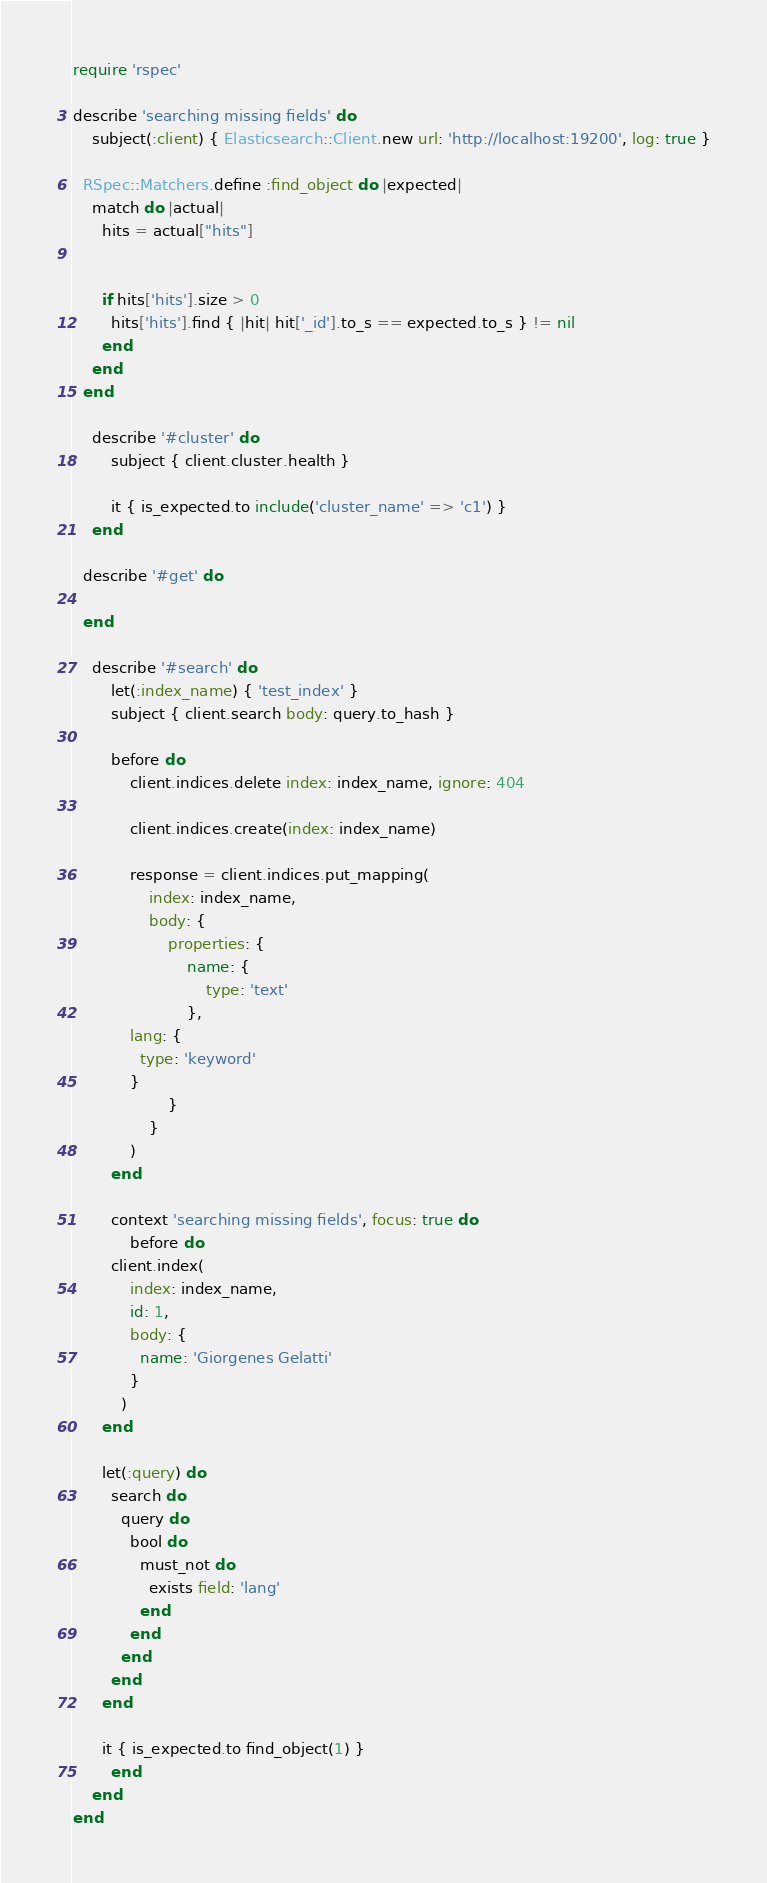<code> <loc_0><loc_0><loc_500><loc_500><_Ruby_>require 'rspec'

describe 'searching missing fields' do
	subject(:client) { Elasticsearch::Client.new url: 'http://localhost:19200', log: true }

  RSpec::Matchers.define :find_object do |expected|
    match do |actual|
      hits = actual["hits"]


      if hits['hits'].size > 0
        hits['hits'].find { |hit| hit['_id'].to_s == expected.to_s } != nil
      end
    end
  end

	describe '#cluster' do
		subject { client.cluster.health }

		it { is_expected.to include('cluster_name' => 'c1') }
	end

  describe '#get' do
    
  end

	describe '#search' do
		let(:index_name) { 'test_index' }
		subject { client.search body: query.to_hash }

		before do
			client.indices.delete index: index_name, ignore: 404

			client.indices.create(index: index_name)

			response = client.indices.put_mapping(
				index: index_name,
				body: {
					properties: {
						name: {
							type: 'text'
						},
            lang: {
              type: 'keyword'
            }
					}
				}
			)
		end

		context 'searching missing fields', focus: true do
			before do
        client.index(
            index: index_name,
            id: 1,
            body: {
              name: 'Giorgenes Gelatti'
            }
          )
      end

      let(:query) do
        search do
          query do
            bool do
              must_not do
                exists field: 'lang'
              end
            end
          end
        end
      end

      it { is_expected.to find_object(1) }
		end
	end
end</code> 